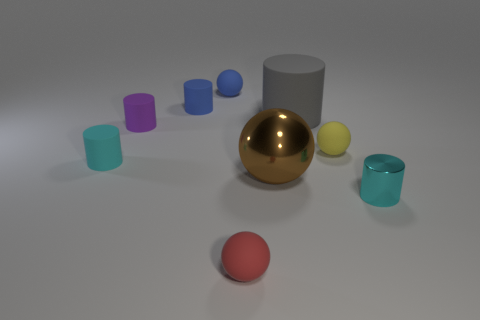Subtract all blue cylinders. How many cylinders are left? 4 Subtract 3 balls. How many balls are left? 1 Add 3 small metal objects. How many small metal objects exist? 4 Subtract all blue balls. How many balls are left? 3 Subtract 1 yellow balls. How many objects are left? 8 Subtract all cylinders. How many objects are left? 4 Subtract all cyan cylinders. Subtract all red spheres. How many cylinders are left? 3 Subtract all green balls. How many brown cylinders are left? 0 Subtract all small shiny cylinders. Subtract all rubber balls. How many objects are left? 5 Add 6 cyan metallic cylinders. How many cyan metallic cylinders are left? 7 